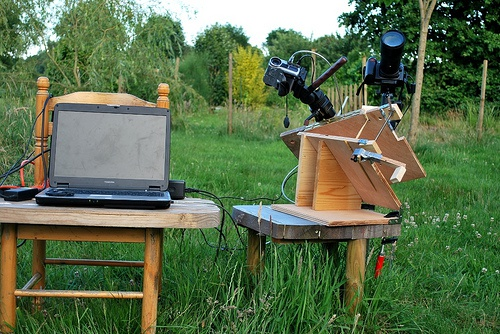Describe the objects in this image and their specific colors. I can see laptop in gray, darkgray, black, and navy tones, chair in gray, black, and darkgreen tones, and chair in gray, tan, and brown tones in this image. 